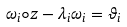<formula> <loc_0><loc_0><loc_500><loc_500>& \omega _ { i } \circ z - \lambda _ { i } \omega _ { i } = \vartheta _ { i }</formula> 